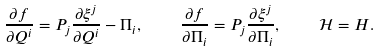<formula> <loc_0><loc_0><loc_500><loc_500>\frac { \partial f } { \partial Q ^ { i } } = P _ { j } \frac { \partial \xi ^ { j } } { \partial Q ^ { i } } - \Pi _ { i } , \quad \frac { \partial f } { \partial \Pi _ { i } } = P _ { j } \frac { \partial \xi ^ { j } } { \partial \Pi _ { i } } , \quad \mathcal { H } = H .</formula> 